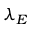<formula> <loc_0><loc_0><loc_500><loc_500>\lambda _ { E }</formula> 